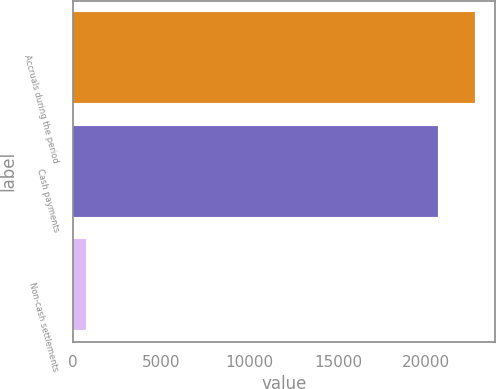Convert chart. <chart><loc_0><loc_0><loc_500><loc_500><bar_chart><fcel>Accruals during the period<fcel>Cash payments<fcel>Non-cash settlements<nl><fcel>22778.8<fcel>20646<fcel>695<nl></chart> 